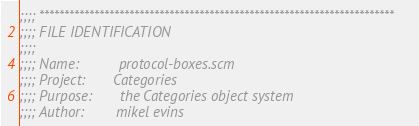Convert code to text. <code><loc_0><loc_0><loc_500><loc_500><_Scheme_>;;;; ***********************************************************************
;;;; FILE IDENTIFICATION
;;;;
;;;; Name:          protocol-boxes.scm
;;;; Project:       Categories
;;;; Purpose:       the Categories object system
;;;; Author:        mikel evins</code> 